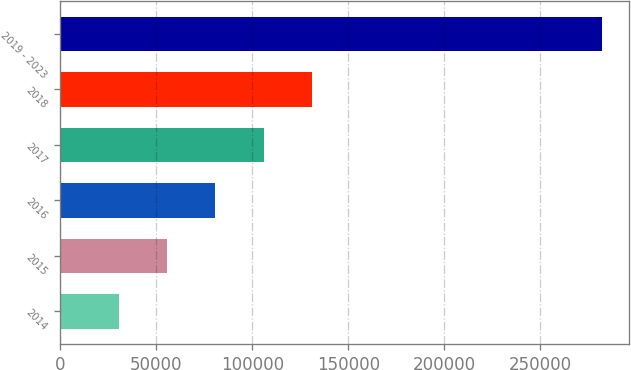<chart> <loc_0><loc_0><loc_500><loc_500><bar_chart><fcel>2014<fcel>2015<fcel>2016<fcel>2017<fcel>2018<fcel>2019 - 2023<nl><fcel>30551<fcel>55684.8<fcel>80818.6<fcel>105952<fcel>131086<fcel>281889<nl></chart> 